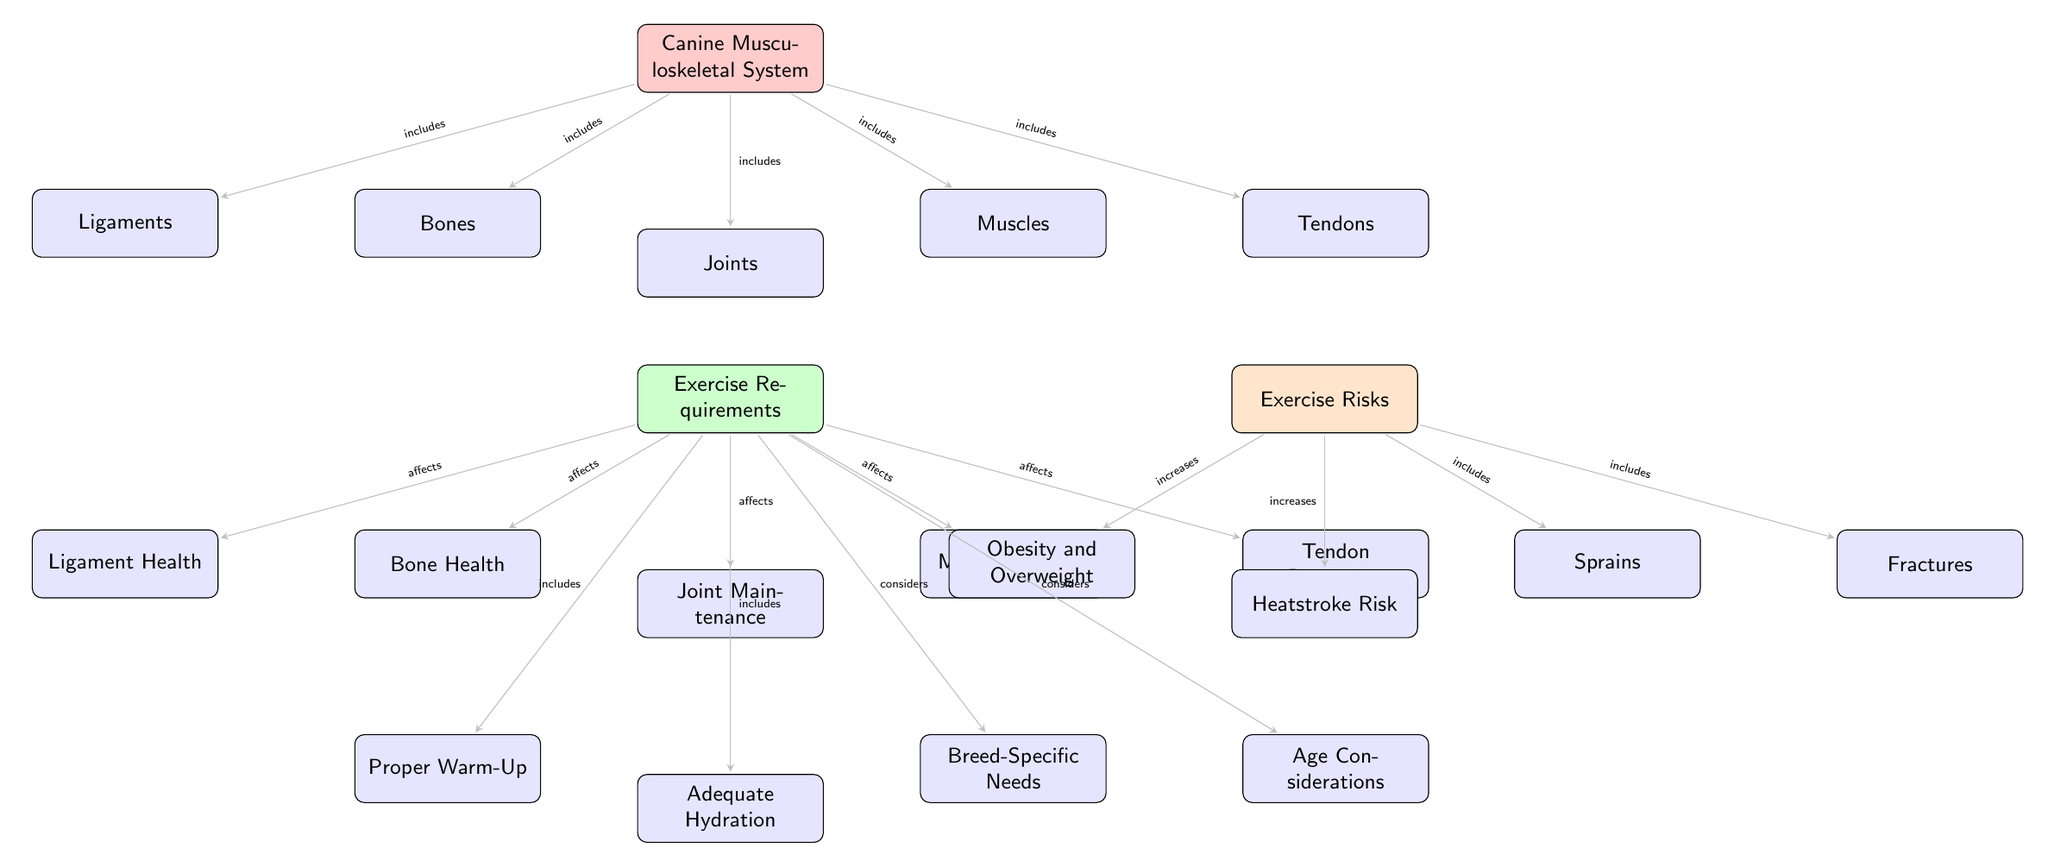What are the components of the Canine Musculoskeletal System? The diagram lists five components: bones, joints, muscles, ligaments, and tendons, which are shown as nodes directly connected to the Canine Musculoskeletal System.
Answer: bones, joints, muscles, ligaments, tendons How many exercise requirements are listed in the diagram? The diagram presents five exercise requirements: bone health, joint maintenance, muscle strength, ligament health, and tendon protection, which indicates a total of five.
Answer: 5 What effect does exercise have on muscle strength? According to the diagram, exercise affects muscle strength, as shown by the directed edge from exercise requirements to muscle strength indicating a direct relationship.
Answer: affects Which exercise requirement specifically considers breed-specific needs? The edge labeled 'considers' connects exercise requirements to the node for breed-specific needs, indicating that it is an exercise requirement focused on this aspect.
Answer: breed-specific needs What risks does inadequate exercise increase for dogs? The risks listed in the diagram include obesity, heatstroke, sprains, and fractures, with each represented as nodes that connect to the exercise risks node, indicating that these conditions increase due to inadequate exercise.
Answer: obesity, heatstroke, sprains, fractures How does exercise affect joint maintenance? The directed edge labeled 'affects' shows that exercise requirements have a direct connection to joint maintenance, indicating that proper exercise has a positive effect.
Answer: affects Which two components of the Canine Musculoskeletal System are related to ligaments? Ligaments are connected to bones and joint maintenance in the diagram, as evidenced by the direct edges leading from each of these nodes to the ligaments node.
Answer: bones, joint maintenance What is a preventative measure included in the exercise requirements? Proper warm-up is explicitly mentioned in the diagram as a part of exercise requirements, identified by the edge labeled 'includes', indicating it’s a preventative measure.
Answer: Proper Warm-Up What is one of the risks of exercise mentioned related to sprains? The edge labeled 'includes' indicates that sprains are connected to exercise risks, meaning they are a specific risk factor related to exercise in dogs.
Answer: Sprains 